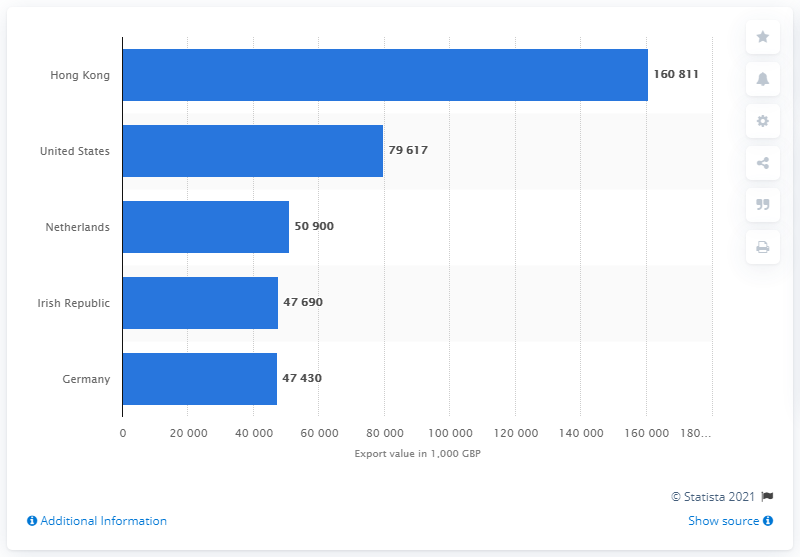Indicate a few pertinent items in this graphic. The sum of German and Netherlands combined is 98330... The Netherlands is a country that has an export value of 50,900. 